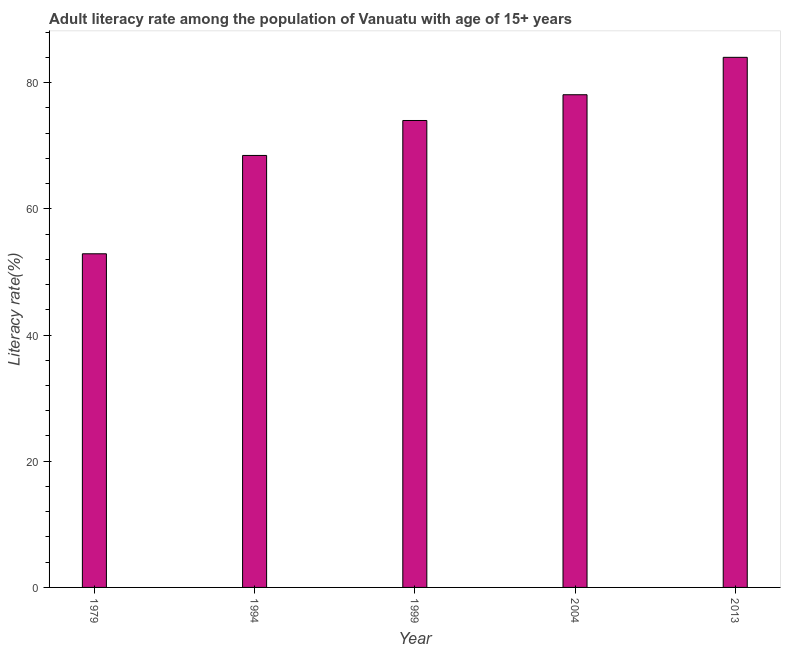Does the graph contain any zero values?
Offer a terse response. No. Does the graph contain grids?
Provide a succinct answer. No. What is the title of the graph?
Give a very brief answer. Adult literacy rate among the population of Vanuatu with age of 15+ years. What is the label or title of the Y-axis?
Keep it short and to the point. Literacy rate(%). What is the adult literacy rate in 1979?
Make the answer very short. 52.87. Across all years, what is the maximum adult literacy rate?
Give a very brief answer. 84.01. Across all years, what is the minimum adult literacy rate?
Offer a very short reply. 52.87. In which year was the adult literacy rate minimum?
Make the answer very short. 1979. What is the sum of the adult literacy rate?
Offer a terse response. 357.42. What is the difference between the adult literacy rate in 1999 and 2004?
Offer a very short reply. -4.08. What is the average adult literacy rate per year?
Offer a terse response. 71.48. What is the median adult literacy rate?
Your answer should be compact. 74. In how many years, is the adult literacy rate greater than 12 %?
Your answer should be very brief. 5. What is the ratio of the adult literacy rate in 1979 to that in 2013?
Give a very brief answer. 0.63. Is the difference between the adult literacy rate in 1979 and 1994 greater than the difference between any two years?
Your response must be concise. No. What is the difference between the highest and the second highest adult literacy rate?
Your answer should be compact. 5.93. What is the difference between the highest and the lowest adult literacy rate?
Provide a succinct answer. 31.14. How many bars are there?
Offer a terse response. 5. Are all the bars in the graph horizontal?
Offer a terse response. No. What is the difference between two consecutive major ticks on the Y-axis?
Provide a succinct answer. 20. What is the Literacy rate(%) of 1979?
Ensure brevity in your answer.  52.87. What is the Literacy rate(%) in 1994?
Your answer should be compact. 68.46. What is the Literacy rate(%) of 2004?
Keep it short and to the point. 78.08. What is the Literacy rate(%) of 2013?
Keep it short and to the point. 84.01. What is the difference between the Literacy rate(%) in 1979 and 1994?
Provide a succinct answer. -15.59. What is the difference between the Literacy rate(%) in 1979 and 1999?
Offer a very short reply. -21.13. What is the difference between the Literacy rate(%) in 1979 and 2004?
Offer a terse response. -25.21. What is the difference between the Literacy rate(%) in 1979 and 2013?
Provide a succinct answer. -31.14. What is the difference between the Literacy rate(%) in 1994 and 1999?
Provide a succinct answer. -5.54. What is the difference between the Literacy rate(%) in 1994 and 2004?
Make the answer very short. -9.62. What is the difference between the Literacy rate(%) in 1994 and 2013?
Give a very brief answer. -15.55. What is the difference between the Literacy rate(%) in 1999 and 2004?
Make the answer very short. -4.08. What is the difference between the Literacy rate(%) in 1999 and 2013?
Provide a short and direct response. -10.01. What is the difference between the Literacy rate(%) in 2004 and 2013?
Give a very brief answer. -5.93. What is the ratio of the Literacy rate(%) in 1979 to that in 1994?
Make the answer very short. 0.77. What is the ratio of the Literacy rate(%) in 1979 to that in 1999?
Your answer should be compact. 0.71. What is the ratio of the Literacy rate(%) in 1979 to that in 2004?
Offer a very short reply. 0.68. What is the ratio of the Literacy rate(%) in 1979 to that in 2013?
Make the answer very short. 0.63. What is the ratio of the Literacy rate(%) in 1994 to that in 1999?
Provide a succinct answer. 0.93. What is the ratio of the Literacy rate(%) in 1994 to that in 2004?
Give a very brief answer. 0.88. What is the ratio of the Literacy rate(%) in 1994 to that in 2013?
Provide a short and direct response. 0.81. What is the ratio of the Literacy rate(%) in 1999 to that in 2004?
Give a very brief answer. 0.95. What is the ratio of the Literacy rate(%) in 1999 to that in 2013?
Make the answer very short. 0.88. What is the ratio of the Literacy rate(%) in 2004 to that in 2013?
Your answer should be very brief. 0.93. 